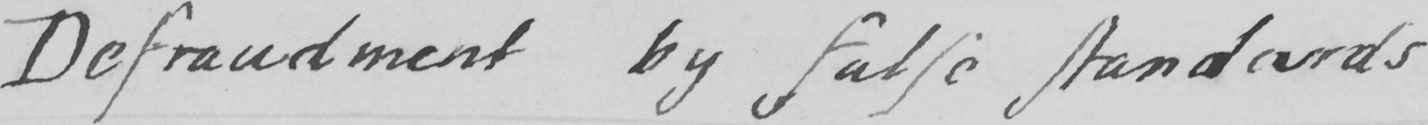What text is written in this handwritten line? Defraudment by false standards 